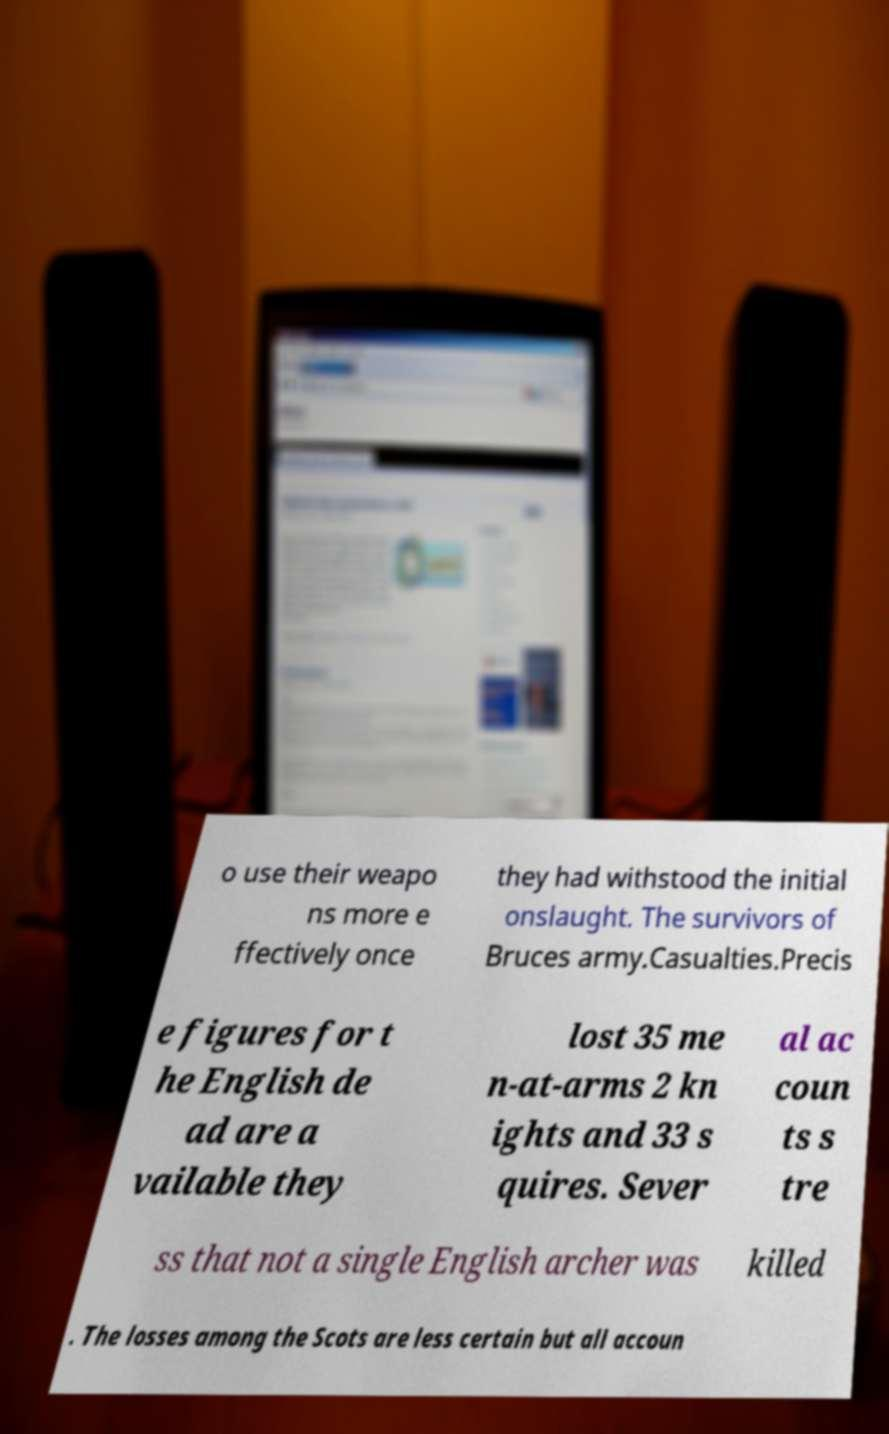Can you accurately transcribe the text from the provided image for me? o use their weapo ns more e ffectively once they had withstood the initial onslaught. The survivors of Bruces army.Casualties.Precis e figures for t he English de ad are a vailable they lost 35 me n-at-arms 2 kn ights and 33 s quires. Sever al ac coun ts s tre ss that not a single English archer was killed . The losses among the Scots are less certain but all accoun 